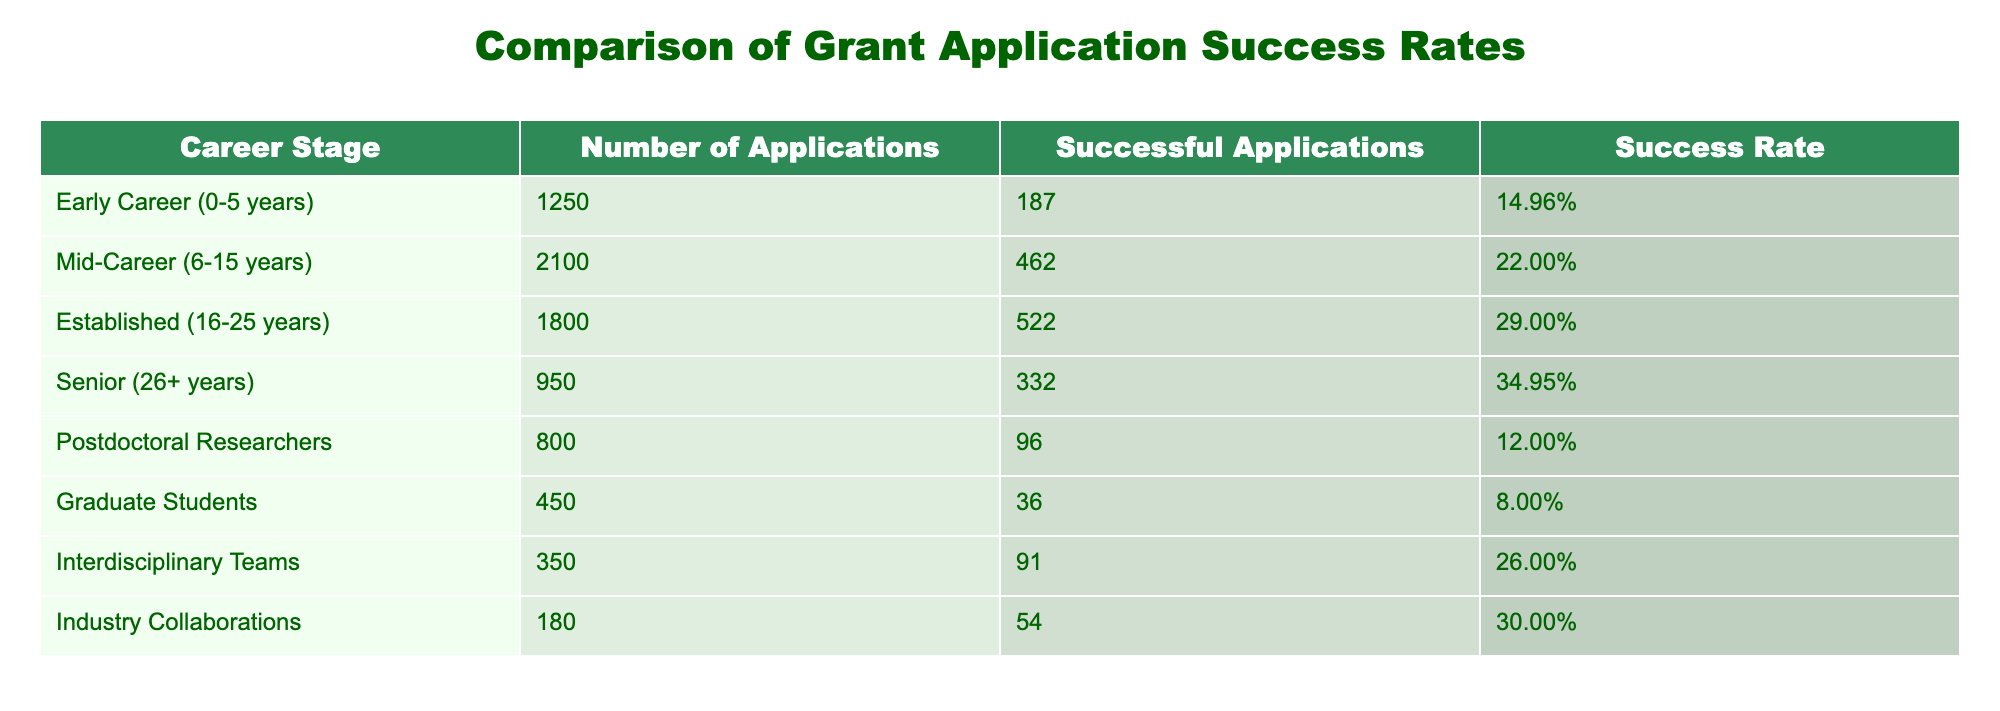What is the success rate for Postdoctoral Researchers? The success rate for Postdoctoral Researchers is directly listed in the table under the column "Success Rate," which indicates a rate of 12.00%.
Answer: 12.00% Which career stage has the highest number of successful applications? To find the career stage with the highest number of successful applications, I look at the "Successful Applications" column and see that Mid-Career (6-15 years) has the highest count at 462 successful applications.
Answer: Mid-Career (6-15 years) What is the difference in success rates between Senior researchers and Graduate Students? The success rate for Senior researchers is 34.95% while Graduate Students have a success rate of 8.00%. The difference is calculated as 34.95% - 8.00% = 26.95%.
Answer: 26.95% Is the success rate for Early Career researchers higher than that for Postdoctoral Researchers? The success rate for Early Career researchers is 14.96% and for Postdoctoral Researchers it is 12.00%. Since 14.96% is greater than 12.00%, the statement is true.
Answer: Yes What is the average success rate across all career stages listed in the table? The success rates for each career stage are: Early Career 14.96%, Mid-Career 22.00%, Established 29.00%, Senior 34.95%, Postdoctoral 12.00%, Graduate Students 8.00%, Interdisciplinary Teams 26.00%, and Industry Collaborations 30.00%. Adding these gives 14.96 + 22.00 + 29.00 + 34.95 + 12.00 + 8.00 + 26.00 + 30.00 =  142.91%. There are 8 career stages, so the average is 142.91% / 8 = 17.86%.
Answer: 17.86% Are there more applications submitted by Industry Collaborations than by Graduate Students? The table shows that Industry Collaborations submitted 180 applications, while Graduate Students submitted 450 applications. Since 180 is less than 450, the statement is false.
Answer: No 